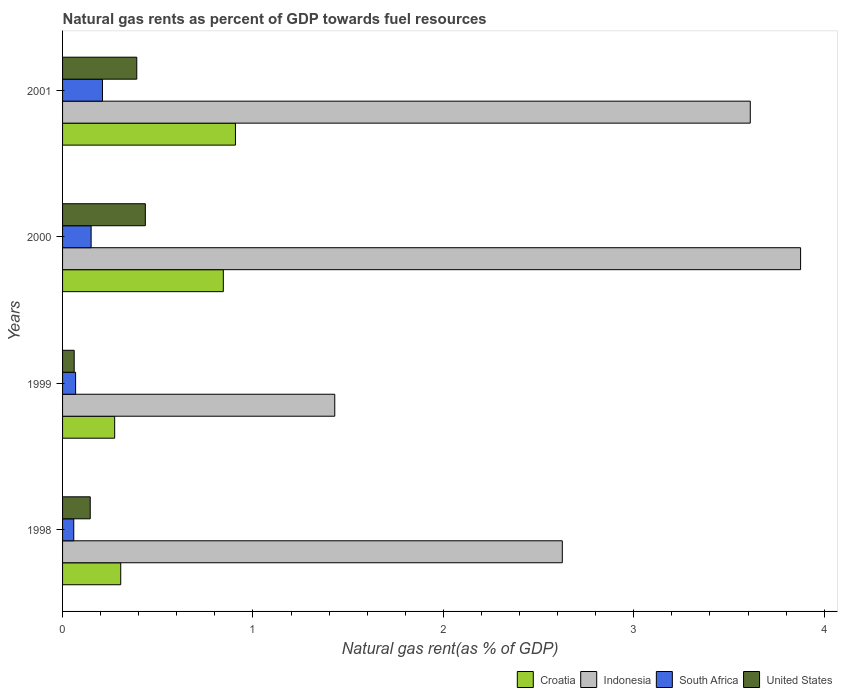How many groups of bars are there?
Ensure brevity in your answer.  4. Are the number of bars per tick equal to the number of legend labels?
Your answer should be compact. Yes. Are the number of bars on each tick of the Y-axis equal?
Provide a short and direct response. Yes. How many bars are there on the 4th tick from the bottom?
Make the answer very short. 4. In how many cases, is the number of bars for a given year not equal to the number of legend labels?
Give a very brief answer. 0. What is the natural gas rent in South Africa in 2000?
Ensure brevity in your answer.  0.15. Across all years, what is the maximum natural gas rent in Indonesia?
Your answer should be very brief. 3.88. Across all years, what is the minimum natural gas rent in United States?
Your answer should be very brief. 0.06. In which year was the natural gas rent in Indonesia maximum?
Offer a very short reply. 2000. What is the total natural gas rent in South Africa in the graph?
Keep it short and to the point. 0.49. What is the difference between the natural gas rent in Indonesia in 2000 and that in 2001?
Your answer should be compact. 0.26. What is the difference between the natural gas rent in United States in 1998 and the natural gas rent in Croatia in 1999?
Provide a short and direct response. -0.13. What is the average natural gas rent in Indonesia per year?
Provide a succinct answer. 2.89. In the year 2000, what is the difference between the natural gas rent in Croatia and natural gas rent in Indonesia?
Keep it short and to the point. -3.03. In how many years, is the natural gas rent in South Africa greater than 1.4 %?
Ensure brevity in your answer.  0. What is the ratio of the natural gas rent in Croatia in 1998 to that in 2000?
Your answer should be compact. 0.36. What is the difference between the highest and the second highest natural gas rent in South Africa?
Provide a short and direct response. 0.06. What is the difference between the highest and the lowest natural gas rent in South Africa?
Provide a short and direct response. 0.15. In how many years, is the natural gas rent in Indonesia greater than the average natural gas rent in Indonesia taken over all years?
Ensure brevity in your answer.  2. Is the sum of the natural gas rent in United States in 1998 and 2000 greater than the maximum natural gas rent in South Africa across all years?
Your response must be concise. Yes. Is it the case that in every year, the sum of the natural gas rent in United States and natural gas rent in South Africa is greater than the sum of natural gas rent in Indonesia and natural gas rent in Croatia?
Provide a short and direct response. No. What does the 2nd bar from the top in 2000 represents?
Ensure brevity in your answer.  South Africa. What does the 3rd bar from the bottom in 2001 represents?
Keep it short and to the point. South Africa. How many bars are there?
Keep it short and to the point. 16. Are the values on the major ticks of X-axis written in scientific E-notation?
Ensure brevity in your answer.  No. Does the graph contain grids?
Offer a terse response. No. Where does the legend appear in the graph?
Your answer should be very brief. Bottom right. How are the legend labels stacked?
Provide a short and direct response. Horizontal. What is the title of the graph?
Your response must be concise. Natural gas rents as percent of GDP towards fuel resources. What is the label or title of the X-axis?
Provide a succinct answer. Natural gas rent(as % of GDP). What is the label or title of the Y-axis?
Provide a short and direct response. Years. What is the Natural gas rent(as % of GDP) in Croatia in 1998?
Provide a succinct answer. 0.31. What is the Natural gas rent(as % of GDP) in Indonesia in 1998?
Provide a short and direct response. 2.62. What is the Natural gas rent(as % of GDP) of South Africa in 1998?
Offer a very short reply. 0.06. What is the Natural gas rent(as % of GDP) of United States in 1998?
Ensure brevity in your answer.  0.15. What is the Natural gas rent(as % of GDP) in Croatia in 1999?
Ensure brevity in your answer.  0.27. What is the Natural gas rent(as % of GDP) in Indonesia in 1999?
Your answer should be compact. 1.43. What is the Natural gas rent(as % of GDP) of South Africa in 1999?
Your response must be concise. 0.07. What is the Natural gas rent(as % of GDP) of United States in 1999?
Give a very brief answer. 0.06. What is the Natural gas rent(as % of GDP) of Croatia in 2000?
Make the answer very short. 0.84. What is the Natural gas rent(as % of GDP) in Indonesia in 2000?
Provide a succinct answer. 3.88. What is the Natural gas rent(as % of GDP) in South Africa in 2000?
Your answer should be very brief. 0.15. What is the Natural gas rent(as % of GDP) in United States in 2000?
Your answer should be very brief. 0.43. What is the Natural gas rent(as % of GDP) of Croatia in 2001?
Provide a short and direct response. 0.91. What is the Natural gas rent(as % of GDP) of Indonesia in 2001?
Your answer should be very brief. 3.61. What is the Natural gas rent(as % of GDP) of South Africa in 2001?
Keep it short and to the point. 0.21. What is the Natural gas rent(as % of GDP) in United States in 2001?
Provide a short and direct response. 0.39. Across all years, what is the maximum Natural gas rent(as % of GDP) of Croatia?
Provide a short and direct response. 0.91. Across all years, what is the maximum Natural gas rent(as % of GDP) in Indonesia?
Make the answer very short. 3.88. Across all years, what is the maximum Natural gas rent(as % of GDP) of South Africa?
Provide a short and direct response. 0.21. Across all years, what is the maximum Natural gas rent(as % of GDP) of United States?
Provide a succinct answer. 0.43. Across all years, what is the minimum Natural gas rent(as % of GDP) of Croatia?
Make the answer very short. 0.27. Across all years, what is the minimum Natural gas rent(as % of GDP) of Indonesia?
Your response must be concise. 1.43. Across all years, what is the minimum Natural gas rent(as % of GDP) of South Africa?
Your answer should be compact. 0.06. Across all years, what is the minimum Natural gas rent(as % of GDP) in United States?
Your answer should be very brief. 0.06. What is the total Natural gas rent(as % of GDP) in Croatia in the graph?
Ensure brevity in your answer.  2.33. What is the total Natural gas rent(as % of GDP) of Indonesia in the graph?
Offer a terse response. 11.54. What is the total Natural gas rent(as % of GDP) in South Africa in the graph?
Ensure brevity in your answer.  0.49. What is the total Natural gas rent(as % of GDP) of United States in the graph?
Your answer should be very brief. 1.03. What is the difference between the Natural gas rent(as % of GDP) of Croatia in 1998 and that in 1999?
Your answer should be very brief. 0.03. What is the difference between the Natural gas rent(as % of GDP) in Indonesia in 1998 and that in 1999?
Provide a succinct answer. 1.2. What is the difference between the Natural gas rent(as % of GDP) of South Africa in 1998 and that in 1999?
Provide a succinct answer. -0.01. What is the difference between the Natural gas rent(as % of GDP) of United States in 1998 and that in 1999?
Your answer should be very brief. 0.08. What is the difference between the Natural gas rent(as % of GDP) in Croatia in 1998 and that in 2000?
Offer a terse response. -0.54. What is the difference between the Natural gas rent(as % of GDP) of Indonesia in 1998 and that in 2000?
Make the answer very short. -1.25. What is the difference between the Natural gas rent(as % of GDP) in South Africa in 1998 and that in 2000?
Offer a very short reply. -0.09. What is the difference between the Natural gas rent(as % of GDP) of United States in 1998 and that in 2000?
Your answer should be compact. -0.29. What is the difference between the Natural gas rent(as % of GDP) of Croatia in 1998 and that in 2001?
Ensure brevity in your answer.  -0.6. What is the difference between the Natural gas rent(as % of GDP) in Indonesia in 1998 and that in 2001?
Your answer should be very brief. -0.99. What is the difference between the Natural gas rent(as % of GDP) in South Africa in 1998 and that in 2001?
Offer a terse response. -0.15. What is the difference between the Natural gas rent(as % of GDP) in United States in 1998 and that in 2001?
Provide a short and direct response. -0.24. What is the difference between the Natural gas rent(as % of GDP) in Croatia in 1999 and that in 2000?
Make the answer very short. -0.57. What is the difference between the Natural gas rent(as % of GDP) of Indonesia in 1999 and that in 2000?
Offer a terse response. -2.45. What is the difference between the Natural gas rent(as % of GDP) of South Africa in 1999 and that in 2000?
Ensure brevity in your answer.  -0.08. What is the difference between the Natural gas rent(as % of GDP) of United States in 1999 and that in 2000?
Keep it short and to the point. -0.37. What is the difference between the Natural gas rent(as % of GDP) in Croatia in 1999 and that in 2001?
Keep it short and to the point. -0.63. What is the difference between the Natural gas rent(as % of GDP) in Indonesia in 1999 and that in 2001?
Your answer should be very brief. -2.18. What is the difference between the Natural gas rent(as % of GDP) in South Africa in 1999 and that in 2001?
Offer a terse response. -0.14. What is the difference between the Natural gas rent(as % of GDP) of United States in 1999 and that in 2001?
Offer a very short reply. -0.33. What is the difference between the Natural gas rent(as % of GDP) in Croatia in 2000 and that in 2001?
Offer a very short reply. -0.06. What is the difference between the Natural gas rent(as % of GDP) of Indonesia in 2000 and that in 2001?
Offer a terse response. 0.26. What is the difference between the Natural gas rent(as % of GDP) of South Africa in 2000 and that in 2001?
Offer a terse response. -0.06. What is the difference between the Natural gas rent(as % of GDP) of United States in 2000 and that in 2001?
Your answer should be compact. 0.04. What is the difference between the Natural gas rent(as % of GDP) of Croatia in 1998 and the Natural gas rent(as % of GDP) of Indonesia in 1999?
Your answer should be compact. -1.12. What is the difference between the Natural gas rent(as % of GDP) of Croatia in 1998 and the Natural gas rent(as % of GDP) of South Africa in 1999?
Keep it short and to the point. 0.24. What is the difference between the Natural gas rent(as % of GDP) of Croatia in 1998 and the Natural gas rent(as % of GDP) of United States in 1999?
Keep it short and to the point. 0.24. What is the difference between the Natural gas rent(as % of GDP) of Indonesia in 1998 and the Natural gas rent(as % of GDP) of South Africa in 1999?
Make the answer very short. 2.56. What is the difference between the Natural gas rent(as % of GDP) of Indonesia in 1998 and the Natural gas rent(as % of GDP) of United States in 1999?
Ensure brevity in your answer.  2.56. What is the difference between the Natural gas rent(as % of GDP) in South Africa in 1998 and the Natural gas rent(as % of GDP) in United States in 1999?
Provide a short and direct response. -0. What is the difference between the Natural gas rent(as % of GDP) of Croatia in 1998 and the Natural gas rent(as % of GDP) of Indonesia in 2000?
Give a very brief answer. -3.57. What is the difference between the Natural gas rent(as % of GDP) in Croatia in 1998 and the Natural gas rent(as % of GDP) in South Africa in 2000?
Your response must be concise. 0.16. What is the difference between the Natural gas rent(as % of GDP) in Croatia in 1998 and the Natural gas rent(as % of GDP) in United States in 2000?
Provide a succinct answer. -0.13. What is the difference between the Natural gas rent(as % of GDP) in Indonesia in 1998 and the Natural gas rent(as % of GDP) in South Africa in 2000?
Provide a short and direct response. 2.47. What is the difference between the Natural gas rent(as % of GDP) of Indonesia in 1998 and the Natural gas rent(as % of GDP) of United States in 2000?
Give a very brief answer. 2.19. What is the difference between the Natural gas rent(as % of GDP) of South Africa in 1998 and the Natural gas rent(as % of GDP) of United States in 2000?
Provide a succinct answer. -0.38. What is the difference between the Natural gas rent(as % of GDP) of Croatia in 1998 and the Natural gas rent(as % of GDP) of Indonesia in 2001?
Make the answer very short. -3.31. What is the difference between the Natural gas rent(as % of GDP) in Croatia in 1998 and the Natural gas rent(as % of GDP) in South Africa in 2001?
Offer a terse response. 0.1. What is the difference between the Natural gas rent(as % of GDP) of Croatia in 1998 and the Natural gas rent(as % of GDP) of United States in 2001?
Your answer should be very brief. -0.08. What is the difference between the Natural gas rent(as % of GDP) in Indonesia in 1998 and the Natural gas rent(as % of GDP) in South Africa in 2001?
Make the answer very short. 2.42. What is the difference between the Natural gas rent(as % of GDP) of Indonesia in 1998 and the Natural gas rent(as % of GDP) of United States in 2001?
Keep it short and to the point. 2.23. What is the difference between the Natural gas rent(as % of GDP) in South Africa in 1998 and the Natural gas rent(as % of GDP) in United States in 2001?
Your answer should be compact. -0.33. What is the difference between the Natural gas rent(as % of GDP) of Croatia in 1999 and the Natural gas rent(as % of GDP) of Indonesia in 2000?
Your answer should be very brief. -3.6. What is the difference between the Natural gas rent(as % of GDP) of Croatia in 1999 and the Natural gas rent(as % of GDP) of South Africa in 2000?
Your response must be concise. 0.12. What is the difference between the Natural gas rent(as % of GDP) in Croatia in 1999 and the Natural gas rent(as % of GDP) in United States in 2000?
Keep it short and to the point. -0.16. What is the difference between the Natural gas rent(as % of GDP) of Indonesia in 1999 and the Natural gas rent(as % of GDP) of South Africa in 2000?
Your answer should be compact. 1.28. What is the difference between the Natural gas rent(as % of GDP) of Indonesia in 1999 and the Natural gas rent(as % of GDP) of United States in 2000?
Give a very brief answer. 0.99. What is the difference between the Natural gas rent(as % of GDP) in South Africa in 1999 and the Natural gas rent(as % of GDP) in United States in 2000?
Your answer should be very brief. -0.37. What is the difference between the Natural gas rent(as % of GDP) of Croatia in 1999 and the Natural gas rent(as % of GDP) of Indonesia in 2001?
Make the answer very short. -3.34. What is the difference between the Natural gas rent(as % of GDP) of Croatia in 1999 and the Natural gas rent(as % of GDP) of South Africa in 2001?
Your answer should be compact. 0.06. What is the difference between the Natural gas rent(as % of GDP) in Croatia in 1999 and the Natural gas rent(as % of GDP) in United States in 2001?
Your answer should be compact. -0.12. What is the difference between the Natural gas rent(as % of GDP) in Indonesia in 1999 and the Natural gas rent(as % of GDP) in South Africa in 2001?
Provide a succinct answer. 1.22. What is the difference between the Natural gas rent(as % of GDP) of Indonesia in 1999 and the Natural gas rent(as % of GDP) of United States in 2001?
Your answer should be very brief. 1.04. What is the difference between the Natural gas rent(as % of GDP) of South Africa in 1999 and the Natural gas rent(as % of GDP) of United States in 2001?
Your answer should be very brief. -0.32. What is the difference between the Natural gas rent(as % of GDP) in Croatia in 2000 and the Natural gas rent(as % of GDP) in Indonesia in 2001?
Ensure brevity in your answer.  -2.77. What is the difference between the Natural gas rent(as % of GDP) in Croatia in 2000 and the Natural gas rent(as % of GDP) in South Africa in 2001?
Provide a short and direct response. 0.63. What is the difference between the Natural gas rent(as % of GDP) in Croatia in 2000 and the Natural gas rent(as % of GDP) in United States in 2001?
Provide a succinct answer. 0.45. What is the difference between the Natural gas rent(as % of GDP) of Indonesia in 2000 and the Natural gas rent(as % of GDP) of South Africa in 2001?
Your response must be concise. 3.67. What is the difference between the Natural gas rent(as % of GDP) of Indonesia in 2000 and the Natural gas rent(as % of GDP) of United States in 2001?
Offer a terse response. 3.49. What is the difference between the Natural gas rent(as % of GDP) in South Africa in 2000 and the Natural gas rent(as % of GDP) in United States in 2001?
Make the answer very short. -0.24. What is the average Natural gas rent(as % of GDP) in Croatia per year?
Ensure brevity in your answer.  0.58. What is the average Natural gas rent(as % of GDP) in Indonesia per year?
Offer a very short reply. 2.89. What is the average Natural gas rent(as % of GDP) of South Africa per year?
Make the answer very short. 0.12. What is the average Natural gas rent(as % of GDP) in United States per year?
Offer a very short reply. 0.26. In the year 1998, what is the difference between the Natural gas rent(as % of GDP) of Croatia and Natural gas rent(as % of GDP) of Indonesia?
Provide a succinct answer. -2.32. In the year 1998, what is the difference between the Natural gas rent(as % of GDP) in Croatia and Natural gas rent(as % of GDP) in South Africa?
Offer a very short reply. 0.25. In the year 1998, what is the difference between the Natural gas rent(as % of GDP) in Croatia and Natural gas rent(as % of GDP) in United States?
Your response must be concise. 0.16. In the year 1998, what is the difference between the Natural gas rent(as % of GDP) in Indonesia and Natural gas rent(as % of GDP) in South Africa?
Offer a very short reply. 2.57. In the year 1998, what is the difference between the Natural gas rent(as % of GDP) in Indonesia and Natural gas rent(as % of GDP) in United States?
Keep it short and to the point. 2.48. In the year 1998, what is the difference between the Natural gas rent(as % of GDP) in South Africa and Natural gas rent(as % of GDP) in United States?
Make the answer very short. -0.09. In the year 1999, what is the difference between the Natural gas rent(as % of GDP) of Croatia and Natural gas rent(as % of GDP) of Indonesia?
Offer a very short reply. -1.16. In the year 1999, what is the difference between the Natural gas rent(as % of GDP) of Croatia and Natural gas rent(as % of GDP) of South Africa?
Make the answer very short. 0.21. In the year 1999, what is the difference between the Natural gas rent(as % of GDP) of Croatia and Natural gas rent(as % of GDP) of United States?
Your answer should be very brief. 0.21. In the year 1999, what is the difference between the Natural gas rent(as % of GDP) of Indonesia and Natural gas rent(as % of GDP) of South Africa?
Offer a terse response. 1.36. In the year 1999, what is the difference between the Natural gas rent(as % of GDP) in Indonesia and Natural gas rent(as % of GDP) in United States?
Provide a succinct answer. 1.37. In the year 1999, what is the difference between the Natural gas rent(as % of GDP) in South Africa and Natural gas rent(as % of GDP) in United States?
Give a very brief answer. 0.01. In the year 2000, what is the difference between the Natural gas rent(as % of GDP) of Croatia and Natural gas rent(as % of GDP) of Indonesia?
Offer a terse response. -3.03. In the year 2000, what is the difference between the Natural gas rent(as % of GDP) of Croatia and Natural gas rent(as % of GDP) of South Africa?
Give a very brief answer. 0.69. In the year 2000, what is the difference between the Natural gas rent(as % of GDP) of Croatia and Natural gas rent(as % of GDP) of United States?
Provide a succinct answer. 0.41. In the year 2000, what is the difference between the Natural gas rent(as % of GDP) of Indonesia and Natural gas rent(as % of GDP) of South Africa?
Your answer should be compact. 3.73. In the year 2000, what is the difference between the Natural gas rent(as % of GDP) of Indonesia and Natural gas rent(as % of GDP) of United States?
Give a very brief answer. 3.44. In the year 2000, what is the difference between the Natural gas rent(as % of GDP) of South Africa and Natural gas rent(as % of GDP) of United States?
Make the answer very short. -0.28. In the year 2001, what is the difference between the Natural gas rent(as % of GDP) of Croatia and Natural gas rent(as % of GDP) of Indonesia?
Provide a short and direct response. -2.7. In the year 2001, what is the difference between the Natural gas rent(as % of GDP) of Croatia and Natural gas rent(as % of GDP) of South Africa?
Your answer should be compact. 0.7. In the year 2001, what is the difference between the Natural gas rent(as % of GDP) in Croatia and Natural gas rent(as % of GDP) in United States?
Offer a very short reply. 0.52. In the year 2001, what is the difference between the Natural gas rent(as % of GDP) in Indonesia and Natural gas rent(as % of GDP) in South Africa?
Your answer should be very brief. 3.4. In the year 2001, what is the difference between the Natural gas rent(as % of GDP) in Indonesia and Natural gas rent(as % of GDP) in United States?
Your answer should be compact. 3.22. In the year 2001, what is the difference between the Natural gas rent(as % of GDP) of South Africa and Natural gas rent(as % of GDP) of United States?
Keep it short and to the point. -0.18. What is the ratio of the Natural gas rent(as % of GDP) of Croatia in 1998 to that in 1999?
Offer a terse response. 1.12. What is the ratio of the Natural gas rent(as % of GDP) in Indonesia in 1998 to that in 1999?
Provide a succinct answer. 1.84. What is the ratio of the Natural gas rent(as % of GDP) of South Africa in 1998 to that in 1999?
Offer a very short reply. 0.86. What is the ratio of the Natural gas rent(as % of GDP) of United States in 1998 to that in 1999?
Keep it short and to the point. 2.38. What is the ratio of the Natural gas rent(as % of GDP) of Croatia in 1998 to that in 2000?
Give a very brief answer. 0.36. What is the ratio of the Natural gas rent(as % of GDP) of Indonesia in 1998 to that in 2000?
Provide a succinct answer. 0.68. What is the ratio of the Natural gas rent(as % of GDP) of South Africa in 1998 to that in 2000?
Offer a very short reply. 0.39. What is the ratio of the Natural gas rent(as % of GDP) in United States in 1998 to that in 2000?
Offer a very short reply. 0.33. What is the ratio of the Natural gas rent(as % of GDP) of Croatia in 1998 to that in 2001?
Your answer should be very brief. 0.34. What is the ratio of the Natural gas rent(as % of GDP) in Indonesia in 1998 to that in 2001?
Ensure brevity in your answer.  0.73. What is the ratio of the Natural gas rent(as % of GDP) of South Africa in 1998 to that in 2001?
Your response must be concise. 0.28. What is the ratio of the Natural gas rent(as % of GDP) in United States in 1998 to that in 2001?
Ensure brevity in your answer.  0.37. What is the ratio of the Natural gas rent(as % of GDP) of Croatia in 1999 to that in 2000?
Keep it short and to the point. 0.32. What is the ratio of the Natural gas rent(as % of GDP) in Indonesia in 1999 to that in 2000?
Offer a very short reply. 0.37. What is the ratio of the Natural gas rent(as % of GDP) in South Africa in 1999 to that in 2000?
Your answer should be very brief. 0.46. What is the ratio of the Natural gas rent(as % of GDP) in United States in 1999 to that in 2000?
Make the answer very short. 0.14. What is the ratio of the Natural gas rent(as % of GDP) of Croatia in 1999 to that in 2001?
Make the answer very short. 0.3. What is the ratio of the Natural gas rent(as % of GDP) in Indonesia in 1999 to that in 2001?
Provide a short and direct response. 0.4. What is the ratio of the Natural gas rent(as % of GDP) of South Africa in 1999 to that in 2001?
Give a very brief answer. 0.33. What is the ratio of the Natural gas rent(as % of GDP) of United States in 1999 to that in 2001?
Your response must be concise. 0.16. What is the ratio of the Natural gas rent(as % of GDP) in Croatia in 2000 to that in 2001?
Your answer should be compact. 0.93. What is the ratio of the Natural gas rent(as % of GDP) of Indonesia in 2000 to that in 2001?
Ensure brevity in your answer.  1.07. What is the ratio of the Natural gas rent(as % of GDP) of South Africa in 2000 to that in 2001?
Keep it short and to the point. 0.72. What is the ratio of the Natural gas rent(as % of GDP) in United States in 2000 to that in 2001?
Offer a very short reply. 1.12. What is the difference between the highest and the second highest Natural gas rent(as % of GDP) in Croatia?
Make the answer very short. 0.06. What is the difference between the highest and the second highest Natural gas rent(as % of GDP) in Indonesia?
Offer a terse response. 0.26. What is the difference between the highest and the second highest Natural gas rent(as % of GDP) of South Africa?
Your response must be concise. 0.06. What is the difference between the highest and the second highest Natural gas rent(as % of GDP) in United States?
Ensure brevity in your answer.  0.04. What is the difference between the highest and the lowest Natural gas rent(as % of GDP) of Croatia?
Ensure brevity in your answer.  0.63. What is the difference between the highest and the lowest Natural gas rent(as % of GDP) in Indonesia?
Offer a very short reply. 2.45. What is the difference between the highest and the lowest Natural gas rent(as % of GDP) in South Africa?
Ensure brevity in your answer.  0.15. What is the difference between the highest and the lowest Natural gas rent(as % of GDP) of United States?
Give a very brief answer. 0.37. 